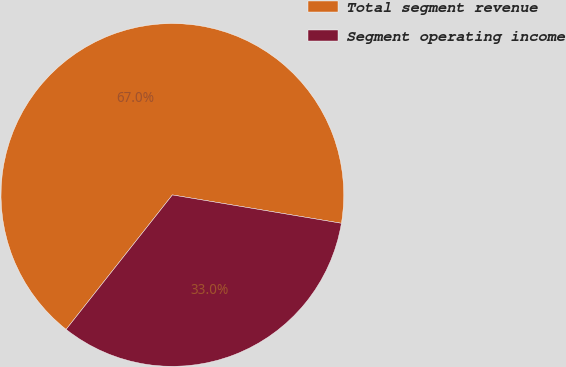Convert chart to OTSL. <chart><loc_0><loc_0><loc_500><loc_500><pie_chart><fcel>Total segment revenue<fcel>Segment operating income<nl><fcel>67.0%<fcel>33.0%<nl></chart> 